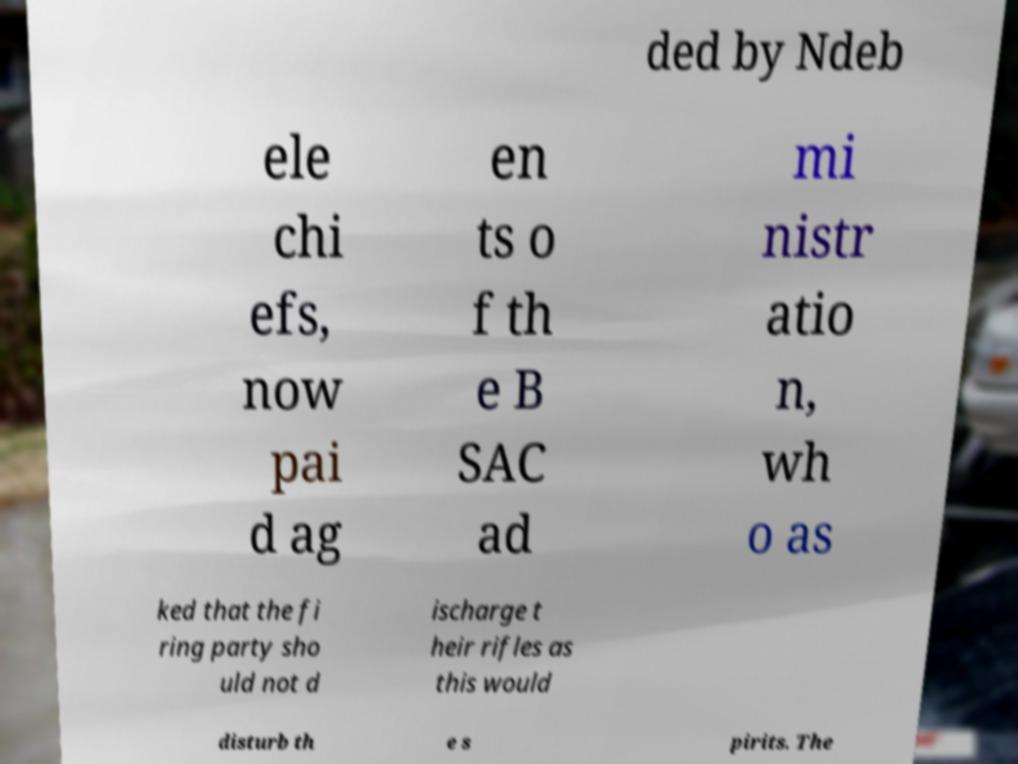Please read and relay the text visible in this image. What does it say? ded by Ndeb ele chi efs, now pai d ag en ts o f th e B SAC ad mi nistr atio n, wh o as ked that the fi ring party sho uld not d ischarge t heir rifles as this would disturb th e s pirits. The 